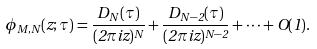Convert formula to latex. <formula><loc_0><loc_0><loc_500><loc_500>\phi _ { M , N } ( z ; \tau ) = \frac { D _ { N } ( \tau ) } { ( 2 \pi i z ) ^ { N } } + \frac { D _ { N - 2 } ( \tau ) } { ( 2 \pi i z ) ^ { N - 2 } } + \dots + O ( 1 ) .</formula> 